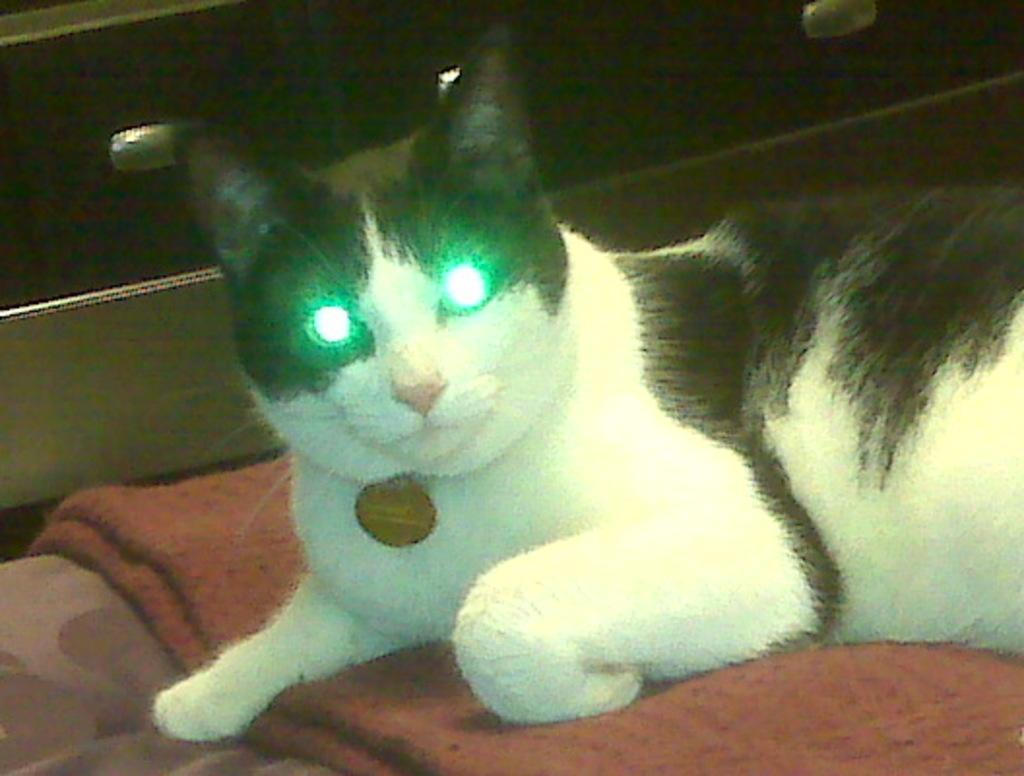What animal is present in the image? There is a cat in the image. Where is the cat located? The cat is on a bed sheet. What is the color of the background in the image? The background of the image is dark. What type of street is visible in the image? There is no street present in the image; it features a cat on a bed sheet with a dark background. What part of the earth can be seen in the image? The image does not show any part of the earth; it only features a cat on a bed sheet with a dark background. 